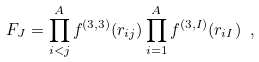<formula> <loc_0><loc_0><loc_500><loc_500>F _ { J } = \prod _ { i < j } ^ { A } f ^ { ( 3 , 3 ) } ( r _ { i j } ) \prod _ { i = 1 } ^ { A } f ^ { ( 3 , I ) } ( r _ { i I } ) \ ,</formula> 